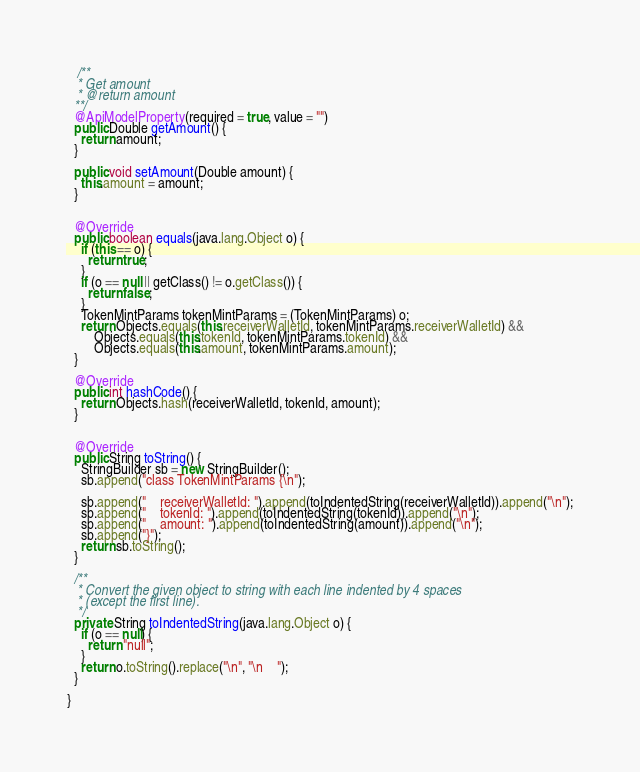Convert code to text. <code><loc_0><loc_0><loc_500><loc_500><_Java_>   /**
   * Get amount
   * @return amount
  **/
  @ApiModelProperty(required = true, value = "")
  public Double getAmount() {
    return amount;
  }

  public void setAmount(Double amount) {
    this.amount = amount;
  }


  @Override
  public boolean equals(java.lang.Object o) {
    if (this == o) {
      return true;
    }
    if (o == null || getClass() != o.getClass()) {
      return false;
    }
    TokenMintParams tokenMintParams = (TokenMintParams) o;
    return Objects.equals(this.receiverWalletId, tokenMintParams.receiverWalletId) &&
        Objects.equals(this.tokenId, tokenMintParams.tokenId) &&
        Objects.equals(this.amount, tokenMintParams.amount);
  }

  @Override
  public int hashCode() {
    return Objects.hash(receiverWalletId, tokenId, amount);
  }


  @Override
  public String toString() {
    StringBuilder sb = new StringBuilder();
    sb.append("class TokenMintParams {\n");
    
    sb.append("    receiverWalletId: ").append(toIndentedString(receiverWalletId)).append("\n");
    sb.append("    tokenId: ").append(toIndentedString(tokenId)).append("\n");
    sb.append("    amount: ").append(toIndentedString(amount)).append("\n");
    sb.append("}");
    return sb.toString();
  }

  /**
   * Convert the given object to string with each line indented by 4 spaces
   * (except the first line).
   */
  private String toIndentedString(java.lang.Object o) {
    if (o == null) {
      return "null";
    }
    return o.toString().replace("\n", "\n    ");
  }

}

</code> 